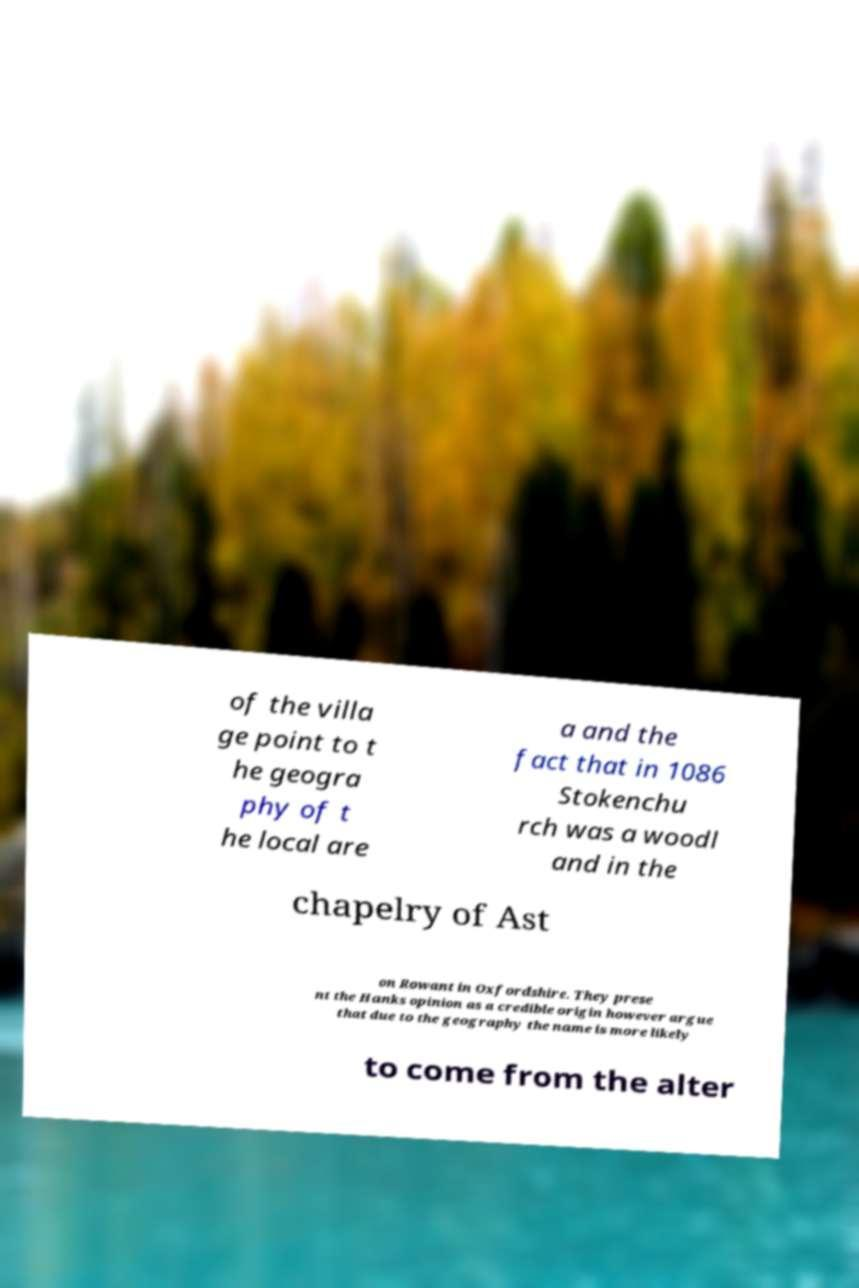Can you read and provide the text displayed in the image?This photo seems to have some interesting text. Can you extract and type it out for me? of the villa ge point to t he geogra phy of t he local are a and the fact that in 1086 Stokenchu rch was a woodl and in the chapelry of Ast on Rowant in Oxfordshire. They prese nt the Hanks opinion as a credible origin however argue that due to the geography the name is more likely to come from the alter 